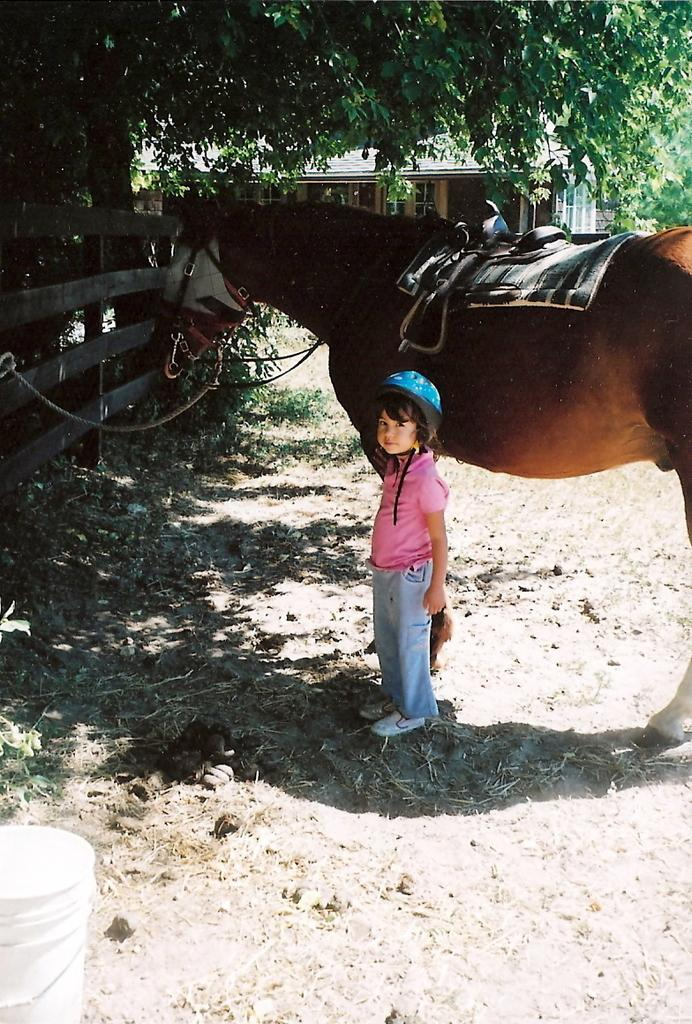Who is the main subject in the image? There is a girl in the image. What is the girl doing in the image? The girl is posing to the camera. What other object or animal is present in the image? There is a horse in the image. How is the girl positioned in relation to the horse? The girl is standing beside the horse. What type of air can be seen around the horse in the image? There is no air visible around the horse in the image. What view can be seen from the horse's perspective in the image? The image does not provide a view from the horse's perspective. 